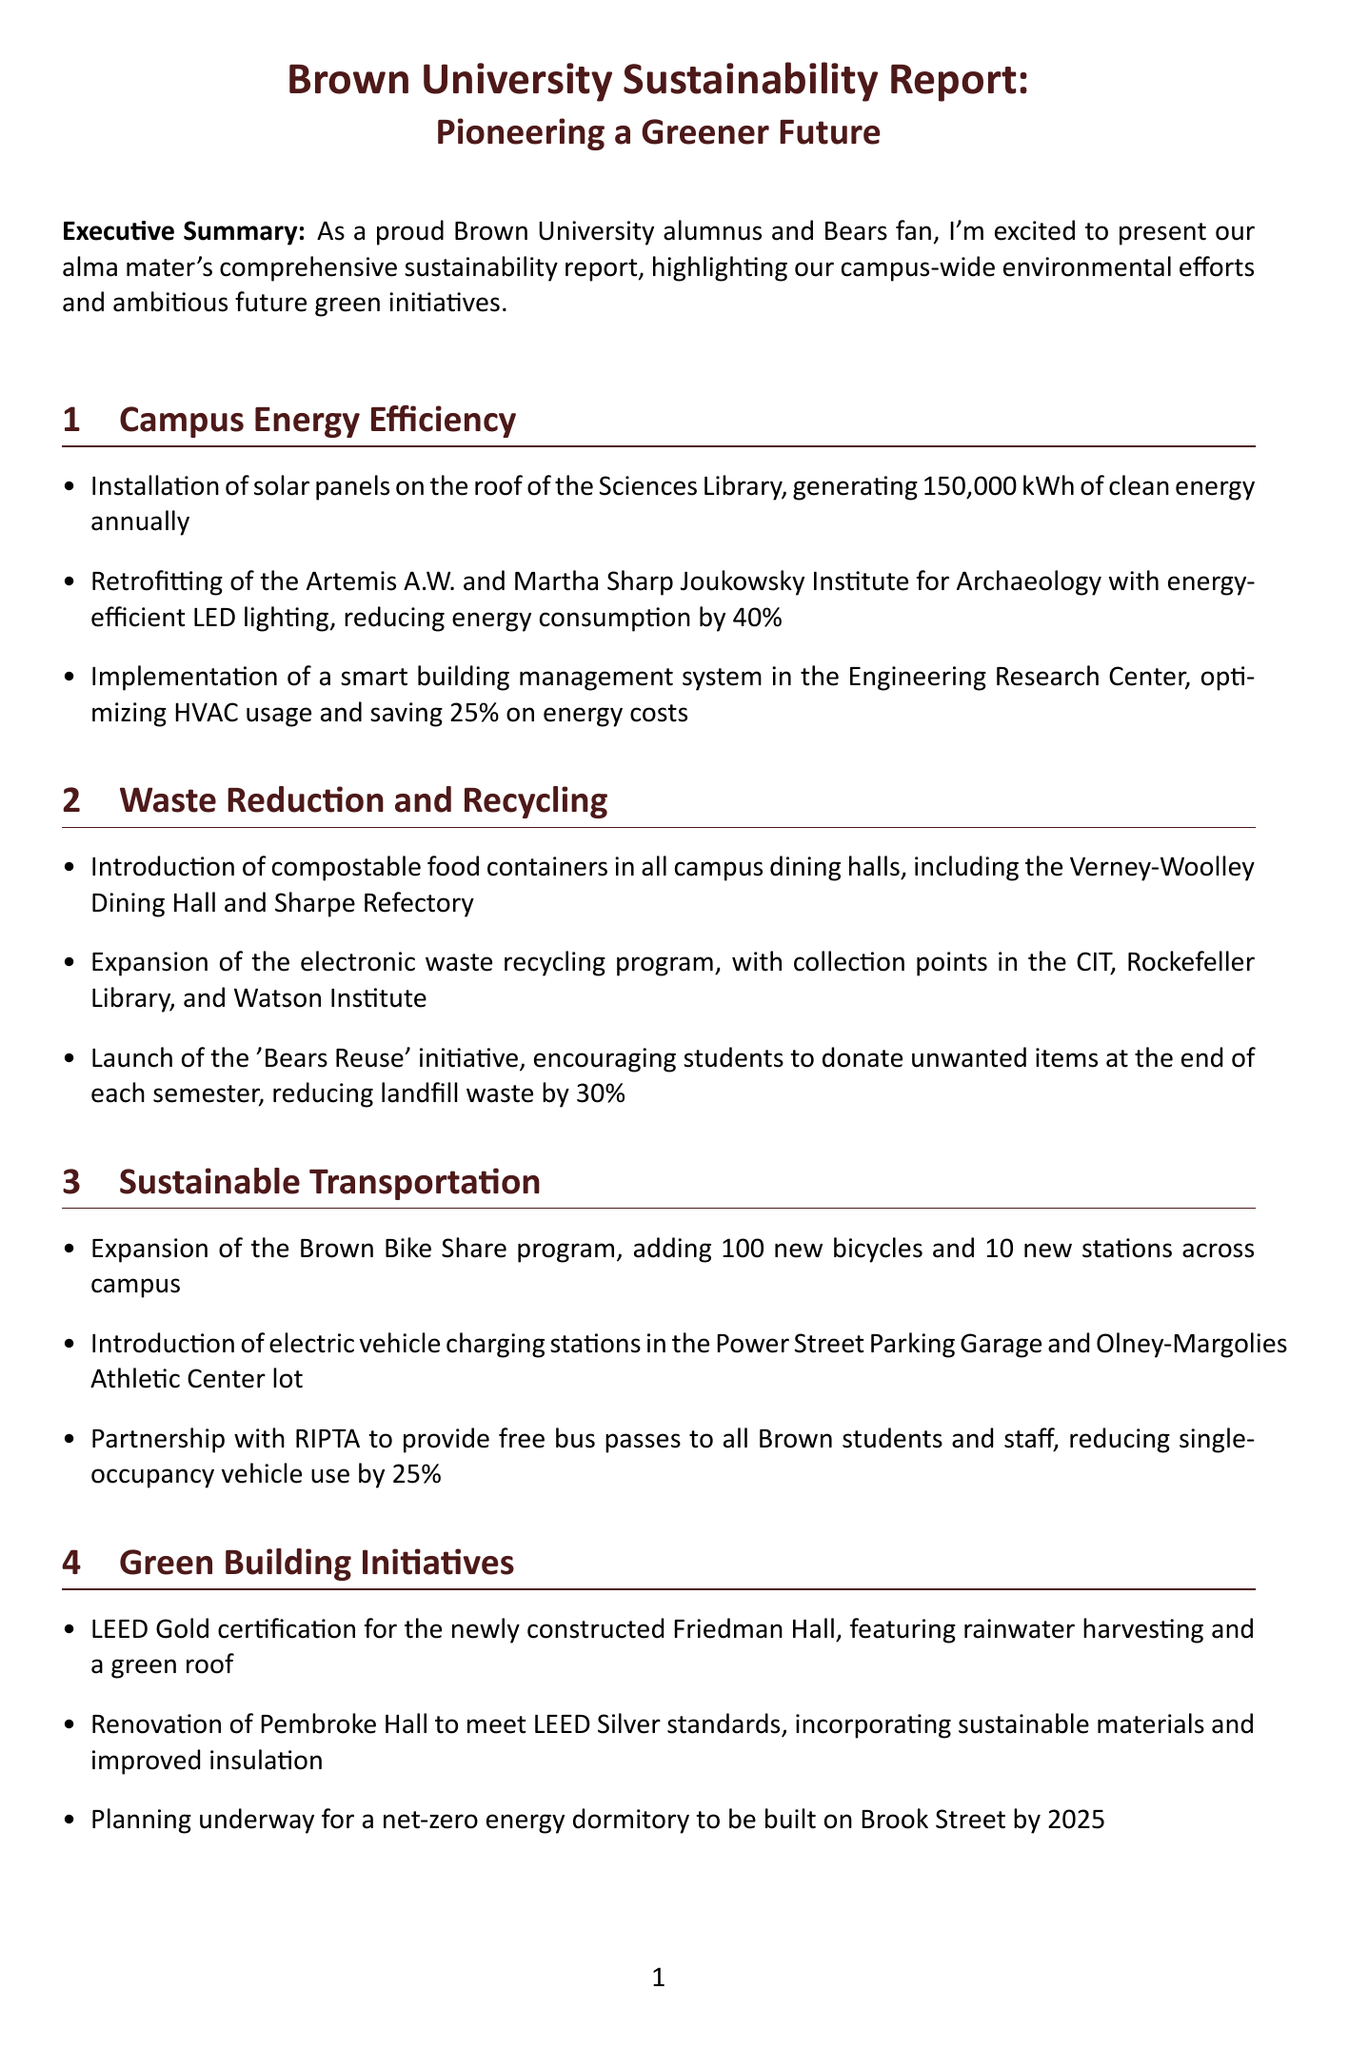What is the title of the report? The title of the report is found at the beginning of the document.
Answer: Brown University Sustainability Report: Pioneering a Greener Future How much clean energy do the solar panels generate annually? The report specifies that the solar panels generate a certain amount of clean energy each year.
Answer: 150,000 kWh What percentage reduction in energy consumption was achieved by the LED lighting retrofitting? The document mentions a specific percentage reduction in energy consumption due to retrofitting with energy-efficient lighting.
Answer: 40% What initiative encourages students to donate unwanted items? The report describes an initiative aimed at reducing landfill waste through donations.
Answer: Bears Reuse By what year does Brown University aim to achieve carbon neutrality? The document outlines a specific goal year for carbon neutrality within the future green initiatives.
Answer: 2040 What is the name of the program launched to support interdisciplinary studies in sustainability? The report mentions a new program in the field of sustainability with a specific name.
Answer: Sustainability Scholars How many trees are being planted in the Urban Forest Initiative? The initiative outlined in the report specifies the number of trees being planted in collaboration with the City of Providence.
Answer: 1,000 trees What type of certification did Friedman Hall receive? The report states the certification level received by the newly constructed Friedman Hall.
Answer: LEED Gold Which two facilities will have electric vehicle charging stations installed? The document provides the names of two specific locations on campus for the installation of charging stations.
Answer: Power Street Parking Garage and Olney-Margolies Athletic Center lot 